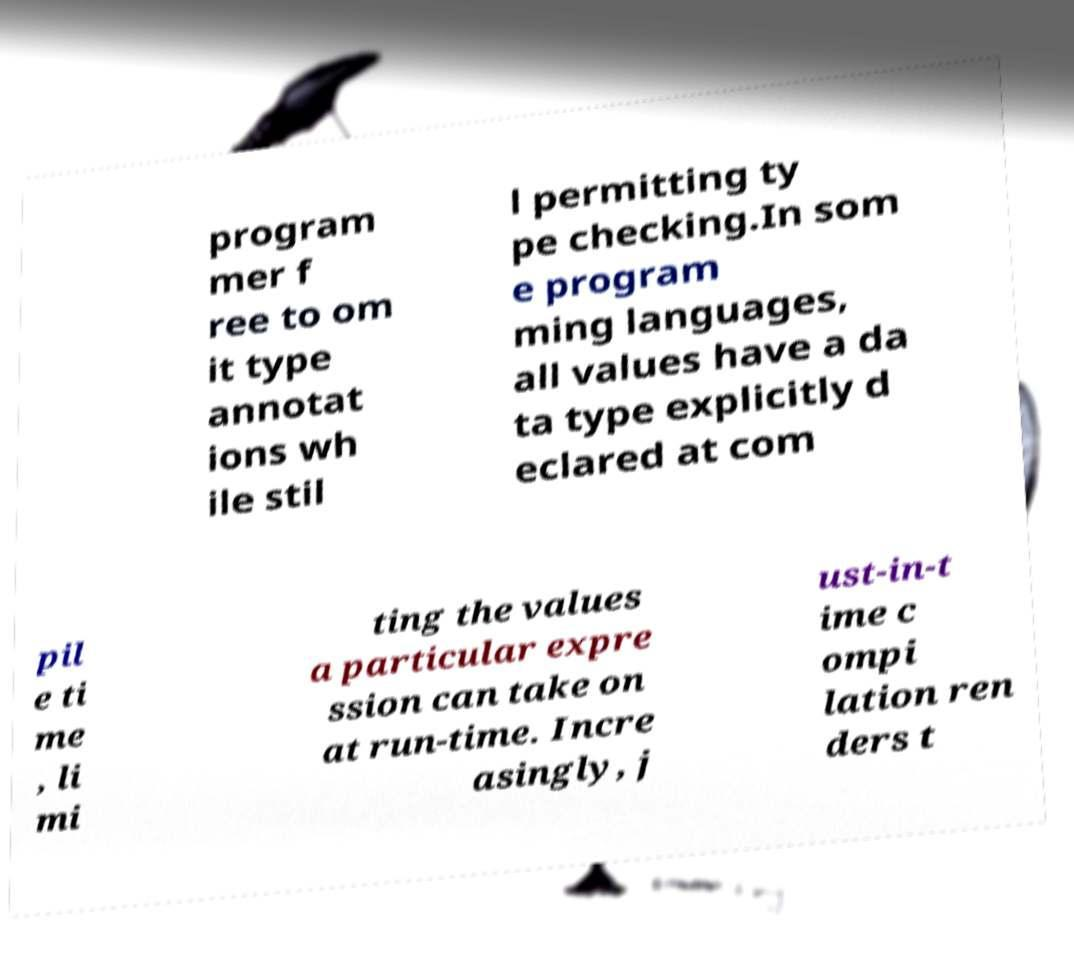Please read and relay the text visible in this image. What does it say? program mer f ree to om it type annotat ions wh ile stil l permitting ty pe checking.In som e program ming languages, all values have a da ta type explicitly d eclared at com pil e ti me , li mi ting the values a particular expre ssion can take on at run-time. Incre asingly, j ust-in-t ime c ompi lation ren ders t 